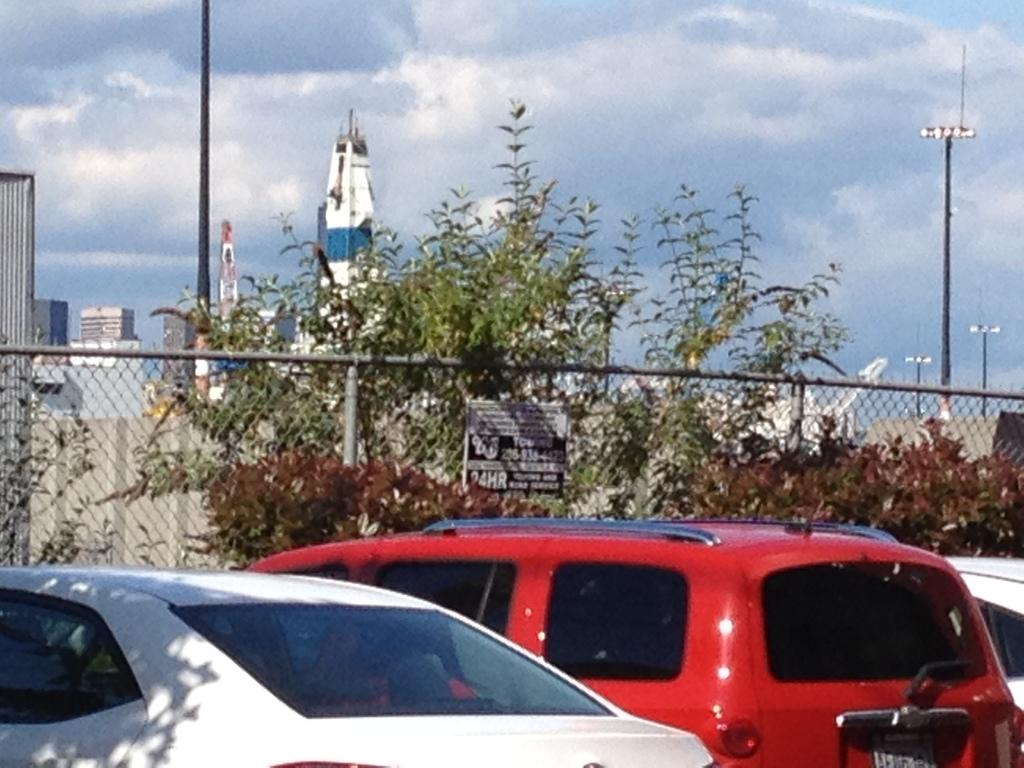What can be seen in the foreground of the image? There are vehicles parked in the foreground of the image. What is visible in the background of the image? In the background of the image, there is fencing, trees, poles, buildings, and the sky. Can you describe the sky in the image? The sky is visible in the background of the image, and there are clouds present. What type of market is visible in the image? There is no market present in the image. What grade of pig can be seen in the image? There are no pigs present in the image. 